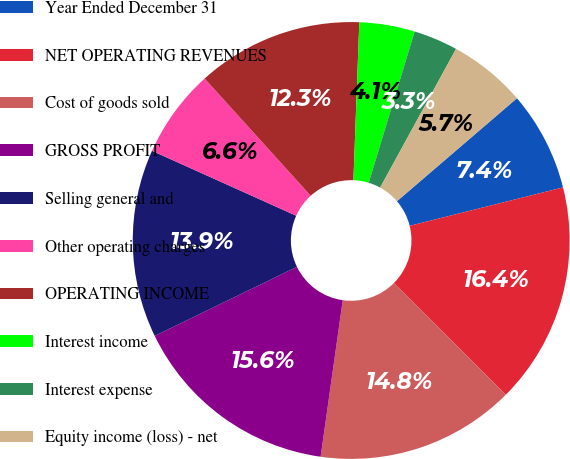<chart> <loc_0><loc_0><loc_500><loc_500><pie_chart><fcel>Year Ended December 31<fcel>NET OPERATING REVENUES<fcel>Cost of goods sold<fcel>GROSS PROFIT<fcel>Selling general and<fcel>Other operating charges<fcel>OPERATING INCOME<fcel>Interest income<fcel>Interest expense<fcel>Equity income (loss) - net<nl><fcel>7.38%<fcel>16.39%<fcel>14.75%<fcel>15.57%<fcel>13.93%<fcel>6.56%<fcel>12.3%<fcel>4.1%<fcel>3.28%<fcel>5.74%<nl></chart> 